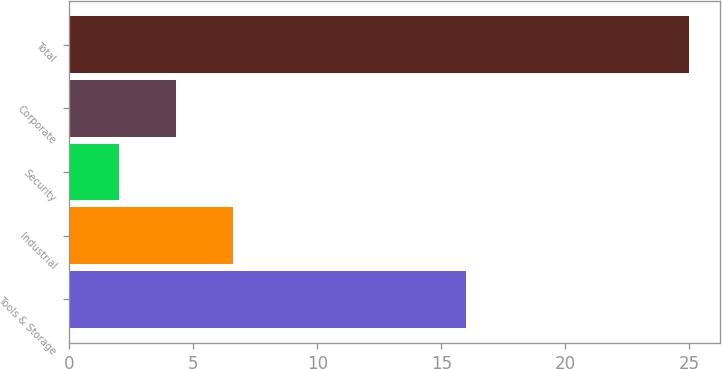<chart> <loc_0><loc_0><loc_500><loc_500><bar_chart><fcel>Tools & Storage<fcel>Industrial<fcel>Security<fcel>Corporate<fcel>Total<nl><fcel>16<fcel>6.6<fcel>2<fcel>4.3<fcel>25<nl></chart> 